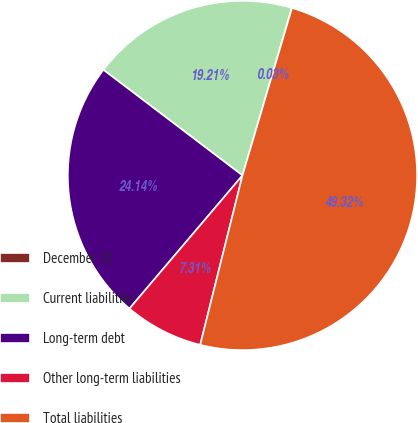Convert chart to OTSL. <chart><loc_0><loc_0><loc_500><loc_500><pie_chart><fcel>December 31<fcel>Current liabilities<fcel>Long-term debt<fcel>Other long-term liabilities<fcel>Total liabilities<nl><fcel>0.03%<fcel>19.21%<fcel>24.14%<fcel>7.31%<fcel>49.32%<nl></chart> 